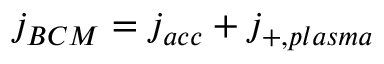Convert formula to latex. <formula><loc_0><loc_0><loc_500><loc_500>j _ { B C M } = j _ { a c c } + j _ { + , p l a s m a }</formula> 